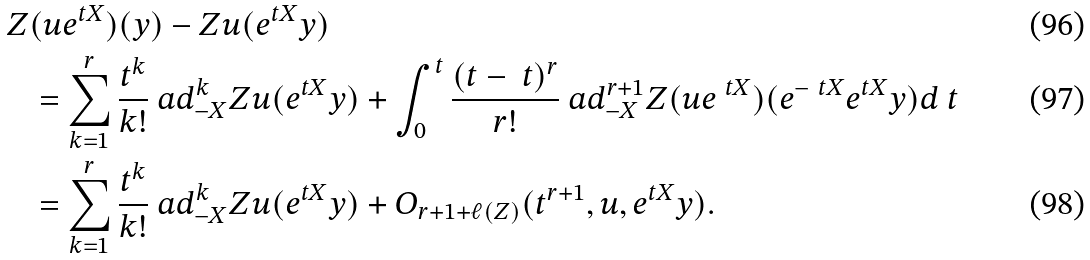Convert formula to latex. <formula><loc_0><loc_0><loc_500><loc_500>Z & ( u e ^ { t X } ) ( y ) - Z u ( e ^ { t X } y ) \\ & = \sum _ { k = 1 } ^ { r } \frac { t ^ { k } } { k ! } \ a d _ { - X } ^ { k } Z u ( e ^ { t X } y ) + \int _ { 0 } ^ { t } \frac { ( t - \ t ) ^ { r } } { r ! } \ a d _ { - X } ^ { r + 1 } Z ( u e ^ { \ t X } ) ( e ^ { - \ t X } e ^ { t X } y ) d \ t \\ & = \sum _ { k = 1 } ^ { r } \frac { t ^ { k } } { k ! } \ a d _ { - X } ^ { k } Z u ( e ^ { t X } y ) + O _ { r + 1 + \ell ( Z ) } ( t ^ { r + 1 } , u , e ^ { t X } y ) .</formula> 